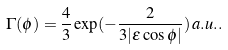Convert formula to latex. <formula><loc_0><loc_0><loc_500><loc_500>\Gamma ( \phi ) = \frac { 4 } { 3 } \exp ( - \frac { 2 } { 3 | \epsilon \cos \phi | } ) \, a . u . .</formula> 